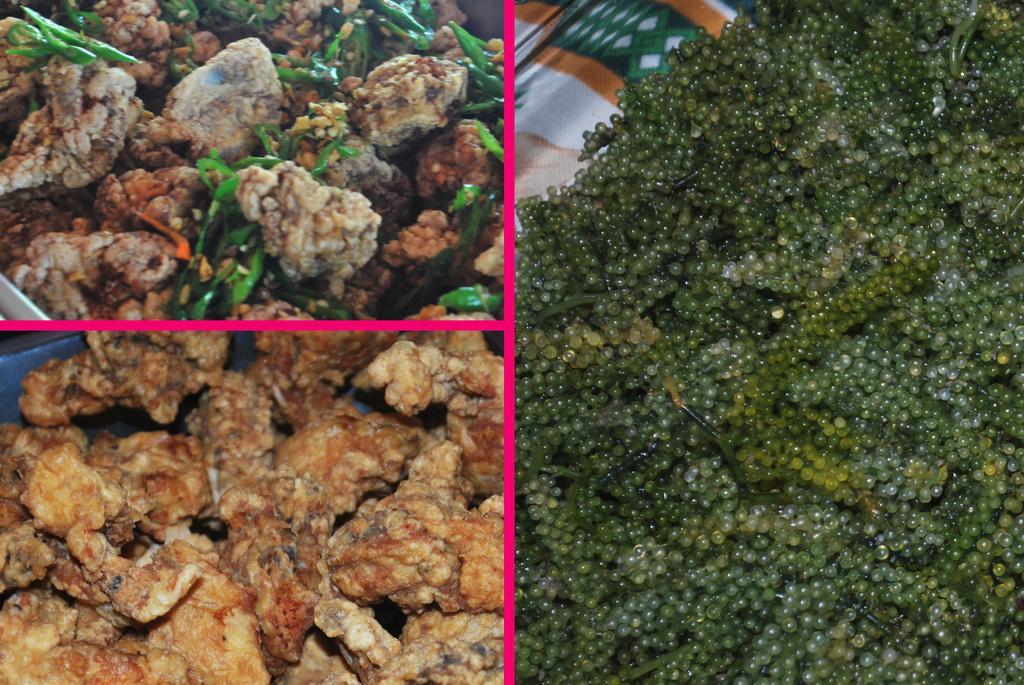Can you describe this image briefly? In this image I can see fruits, nuts, meat items and food items. This image looks like an edited photo. 